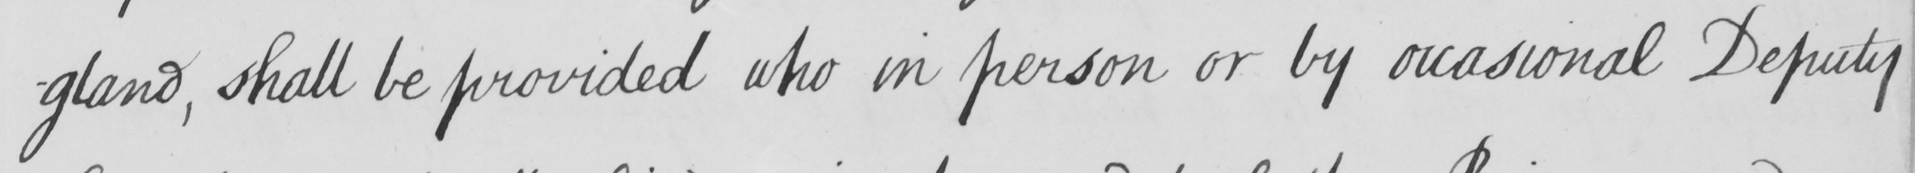What is written in this line of handwriting? -gland , shall be provided who in person or by occasional Deputy 